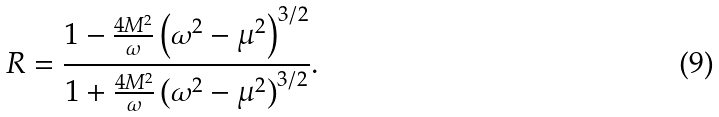Convert formula to latex. <formula><loc_0><loc_0><loc_500><loc_500>R = \frac { 1 - \frac { 4 M ^ { 2 } } { \omega } \left ( \omega ^ { 2 } - \mu ^ { 2 } \right ) ^ { 3 / 2 } } { 1 + \frac { 4 M ^ { 2 } } { \omega } \left ( \omega ^ { 2 } - \mu ^ { 2 } \right ) ^ { 3 / 2 } } .</formula> 